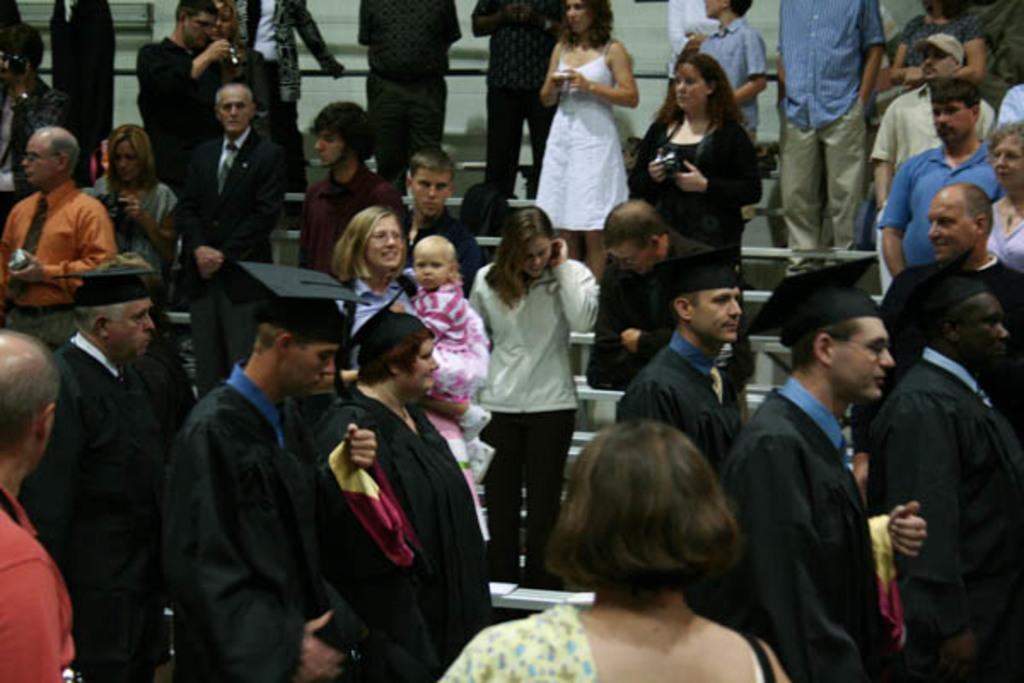Who or what can be seen in the image? There are people in the image. What are the people wearing? The people are wearing black color gowns and hats. What architectural feature is visible in the image? There are stairs visible in the image. What type of disease is affecting the people in the image? There is no indication of any disease affecting the people in the image. What is the skin color of the people in the image? The provided facts do not mention the skin color of the people in the image. 